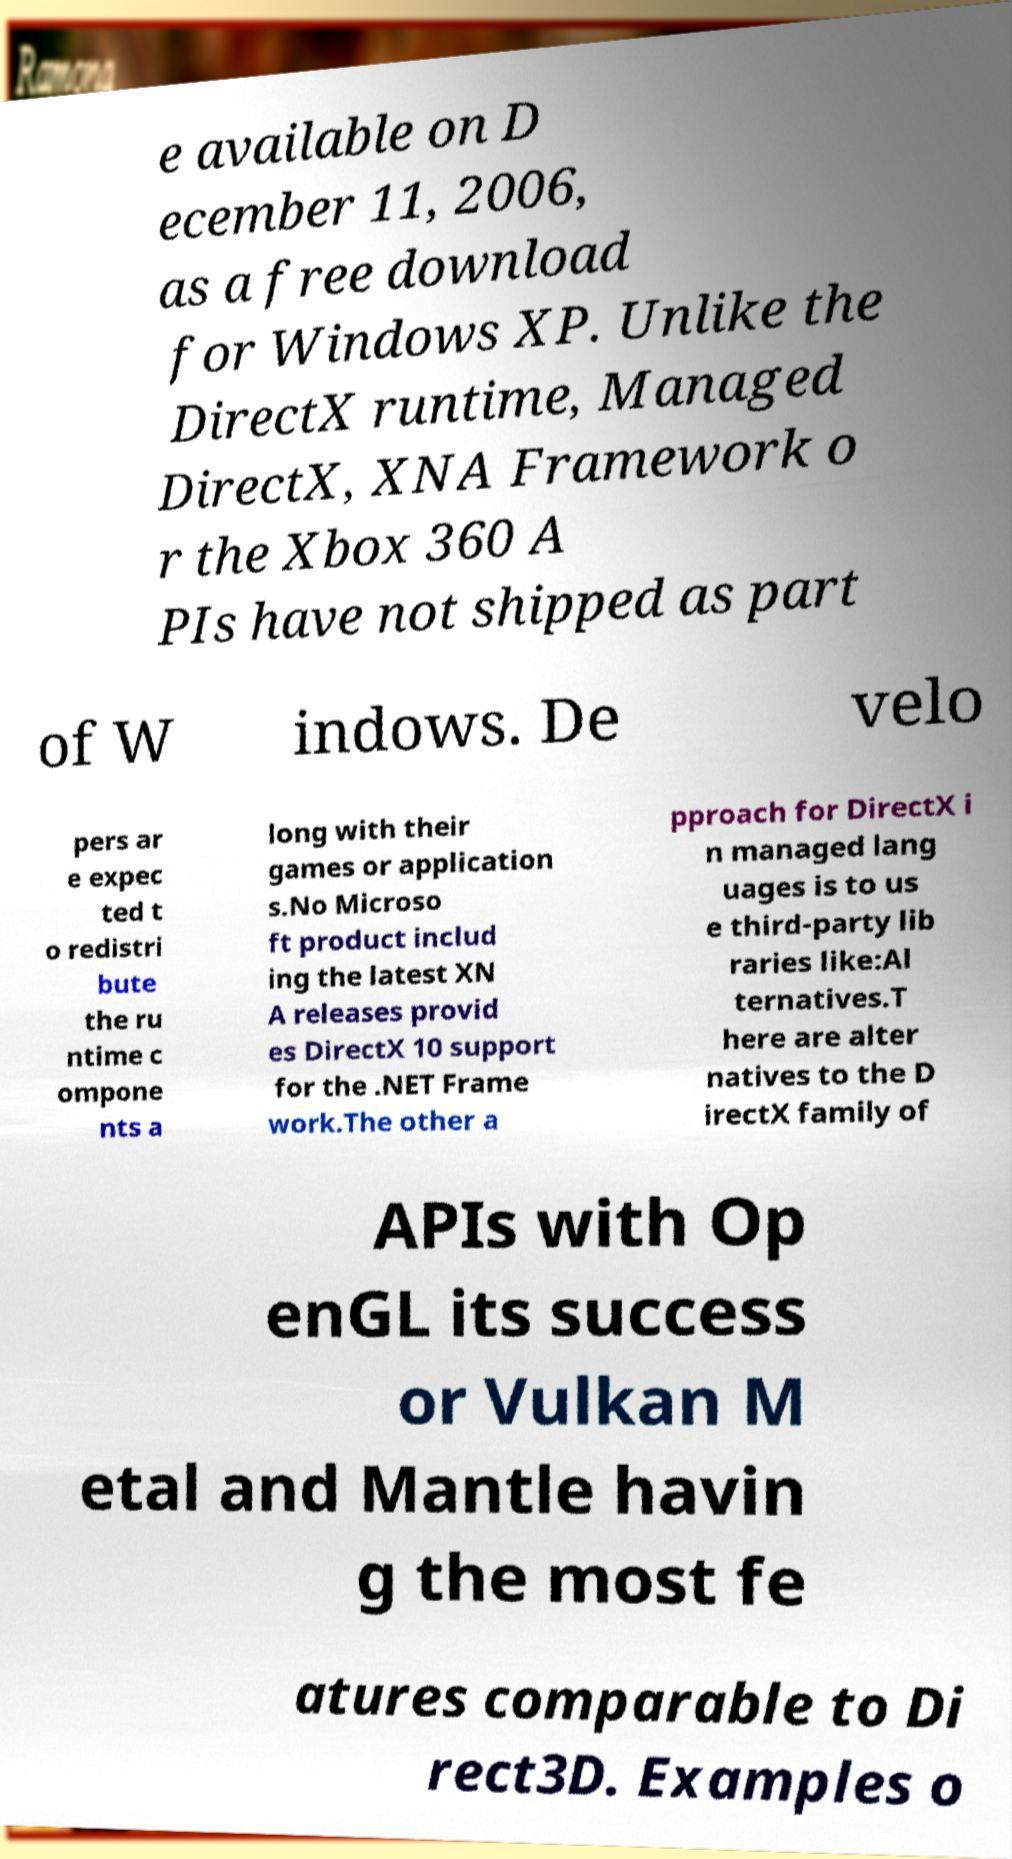For documentation purposes, I need the text within this image transcribed. Could you provide that? e available on D ecember 11, 2006, as a free download for Windows XP. Unlike the DirectX runtime, Managed DirectX, XNA Framework o r the Xbox 360 A PIs have not shipped as part of W indows. De velo pers ar e expec ted t o redistri bute the ru ntime c ompone nts a long with their games or application s.No Microso ft product includ ing the latest XN A releases provid es DirectX 10 support for the .NET Frame work.The other a pproach for DirectX i n managed lang uages is to us e third-party lib raries like:Al ternatives.T here are alter natives to the D irectX family of APIs with Op enGL its success or Vulkan M etal and Mantle havin g the most fe atures comparable to Di rect3D. Examples o 